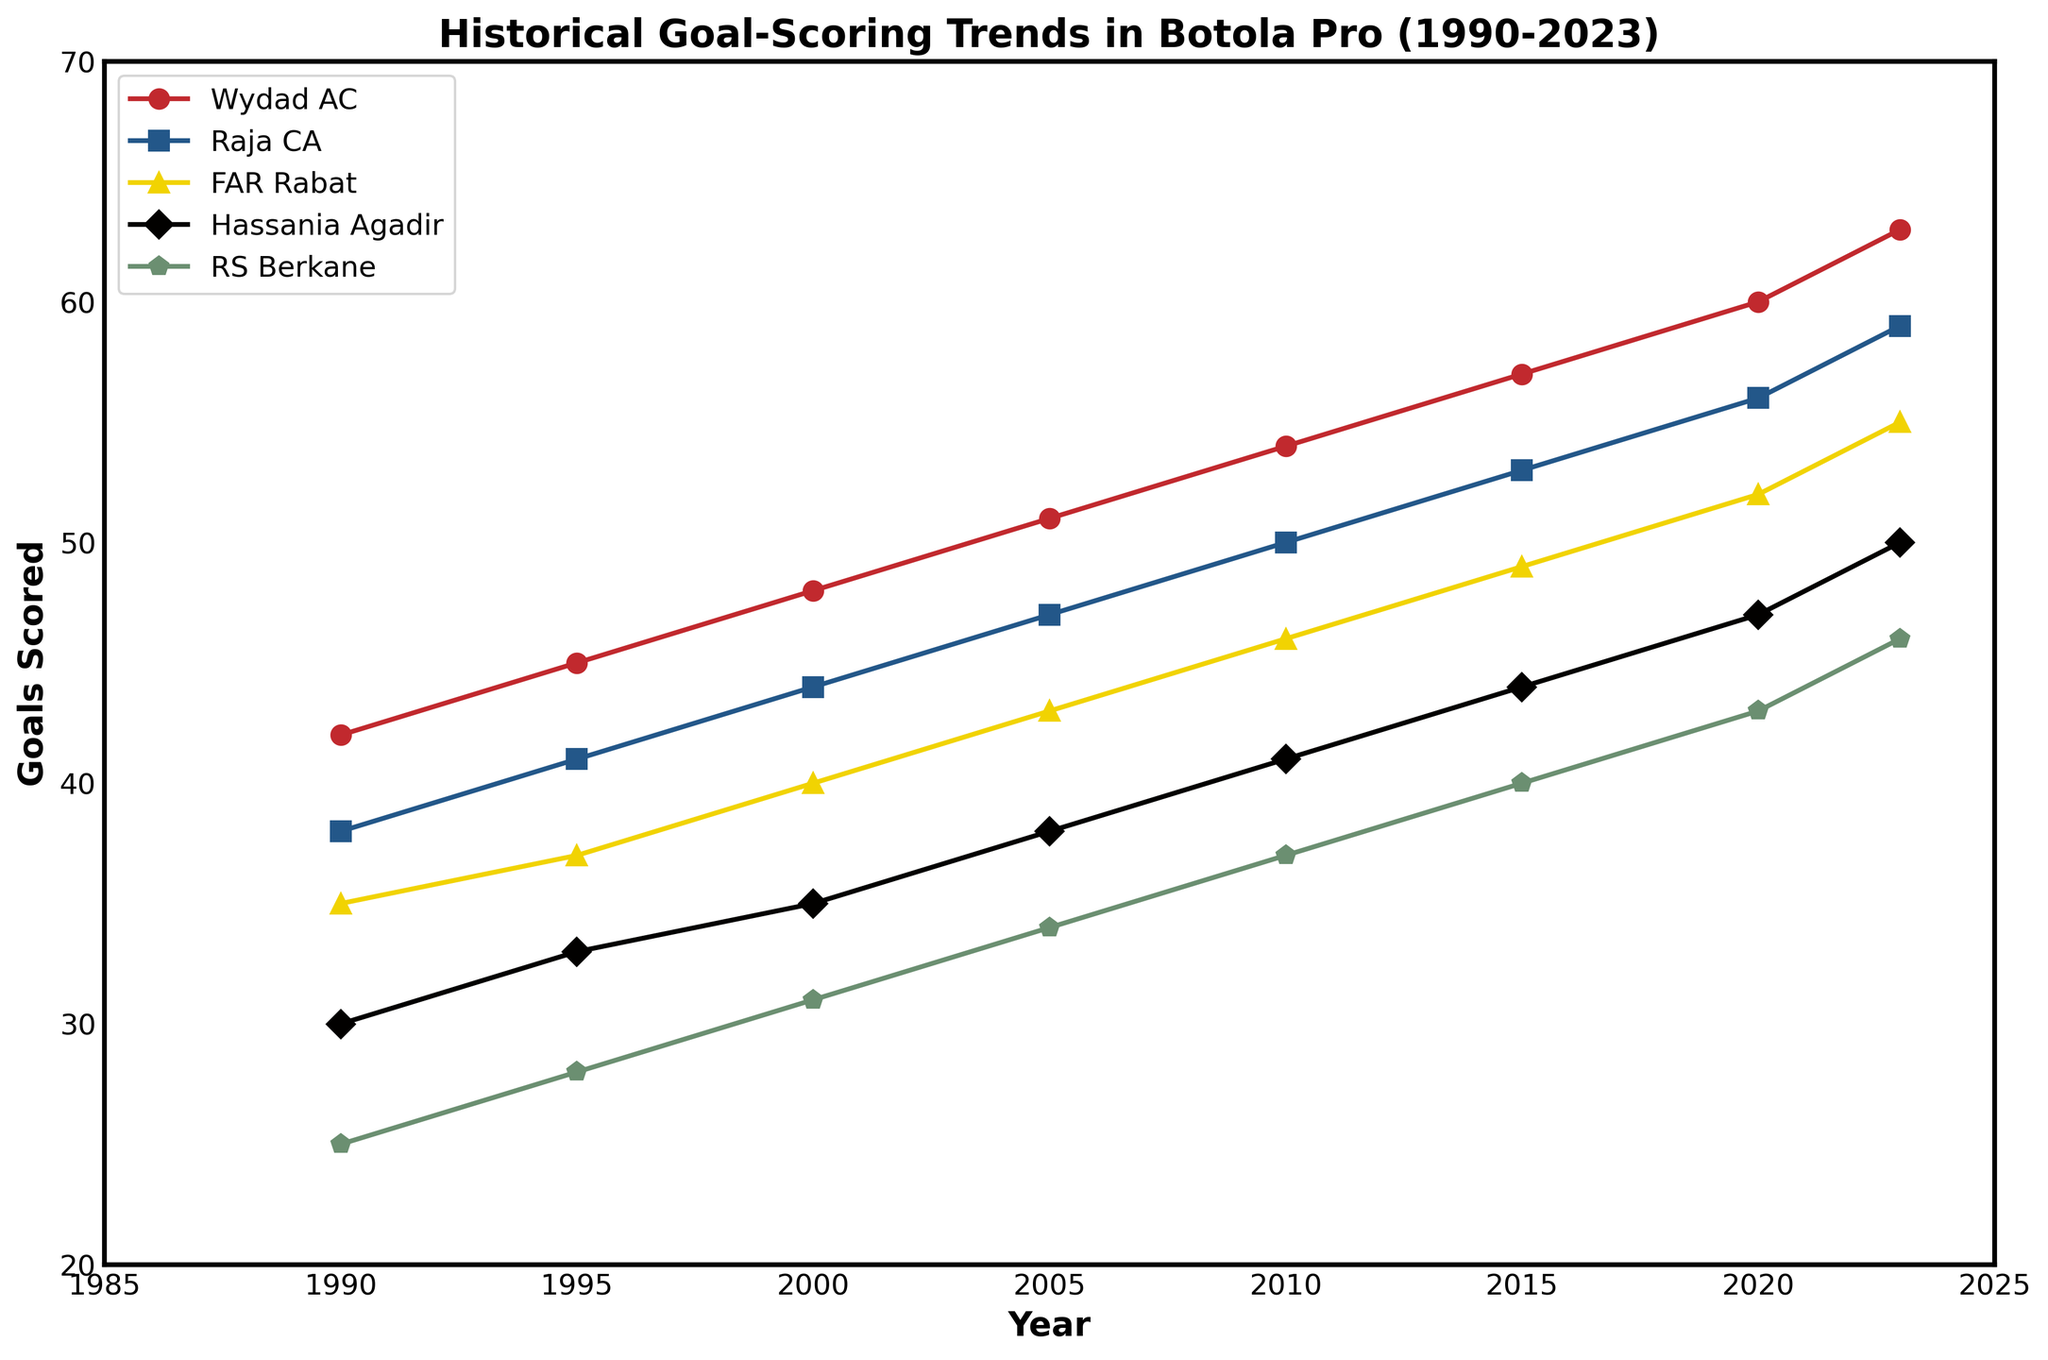Which team scored the most goals in 2023? Look at the endpoints (2023) of the lines representing each team and identify the one with the highest value. Wydad AC scored 63 goals in 2023, which is the maximum among all teams.
Answer: Wydad AC How many more goals did Raja CA score compared to RS Berkane in 2010? Find the values for Raja CA and RS Berkane in 2010, which are 50 and 37 respectively. Calculate the difference: 50 - 37 = 13.
Answer: 13 What is the average number of goals scored by FAR Rabat from 1990 to 2023? Add the goals scored by FAR Rabat in each year (35, 37, 40, 43, 46, 49, 52, 55) and divide by the number of years (8). (35 + 37 + 40 + 43 + 46 + 49 + 52 + 55) / 8 = 357 / 8 = 44.625
Answer: 44.625 Between which years did Hassania Agadir increase their goal count the most? Compare the increase in goals for each year interval for Hassania Agadir: 1990-1995 (30 to 33 = +3), 1995-2000 (33 to 35 = +2), 2000-2005 (35 to 38 = +3), 2005-2010 (38 to 41 = +3), 2010-2015 (41 to 44 = +3), 2015-2020 (44 to 47 = +3), 2020-2023 (47 to 50 = +3). The increases are the same (3 goals) for each period, hence there is no single period with more increase.
Answer: All intervals Which team has the steepest increase in goals from 1990 to 2023? Compare the slopes (rise over run) of each team's line: Wydad AC (63-42 = 21), Raja CA (59-38 = 21), FAR Rabat (55-35 = 20), Hassania Agadir (50-30 = 20), RS Berkane (46-25 = 21). The total period is 33 years. The steepest increases are equal for Wydad AC, Raja CA, and RS Berkane: 21/33 years = 0.636 goals per year.
Answer: Wydad AC, Raja CA, RS Berkane How did the number of goals scored by RS Berkane change from 1990 to 2023? Identify the values for RS Berkane in these years: 1990 (25) and 2023 (46). Calculate the change: 46 - 25 = 21.
Answer: Increased by 21 Which two teams had the closest goal counts in 1995? Compare the values for each team in 1995: Wydad AC (45), Raja CA (41), FAR Rabat (37), Hassania Agadir (33), RS Berkane (28). The closest values are Raja CA and FAR Rabat: 41 - 37 = 4.
Answer: Raja CA and FAR Rabat What was the overall trend in goal-scoring for Wydad AC from 1990 to 2023? Observe the line for Wydad AC from 1990 to 2023. The line consistently rises, indicating an overall increasing trend.
Answer: Increasing 